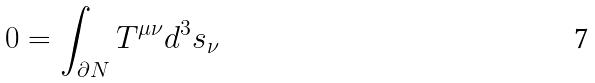<formula> <loc_0><loc_0><loc_500><loc_500>0 = \int _ { \partial N } T ^ { \mu \nu } d ^ { 3 } s _ { \nu }</formula> 